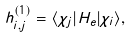<formula> <loc_0><loc_0><loc_500><loc_500>h ^ { ( 1 ) } _ { i , j } = \langle \chi _ { j } | H _ { e } | \chi _ { i } \rangle ,</formula> 